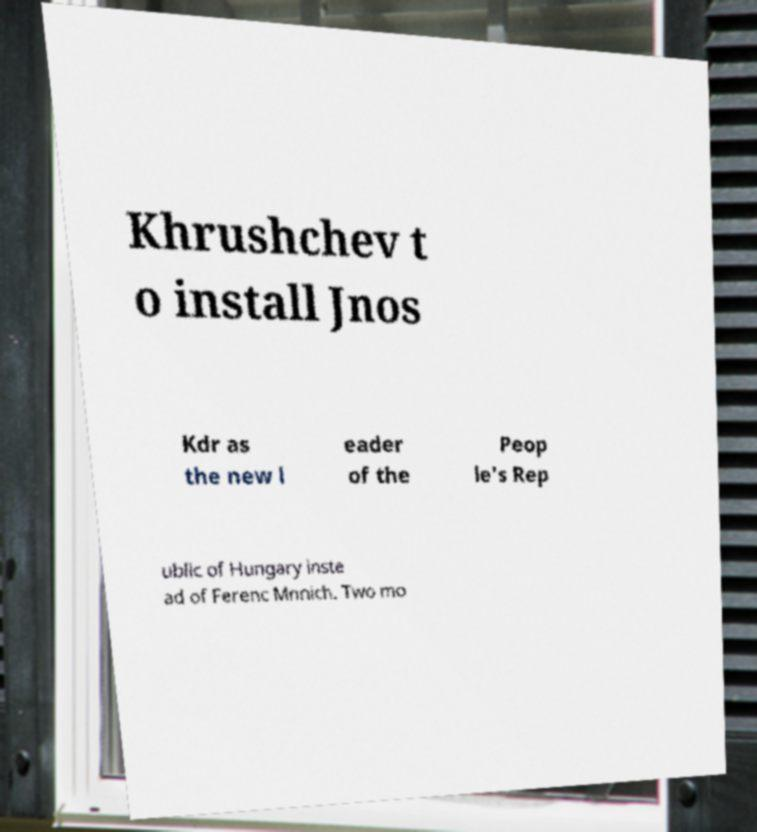Please identify and transcribe the text found in this image. Khrushchev t o install Jnos Kdr as the new l eader of the Peop le's Rep ublic of Hungary inste ad of Ferenc Mnnich. Two mo 